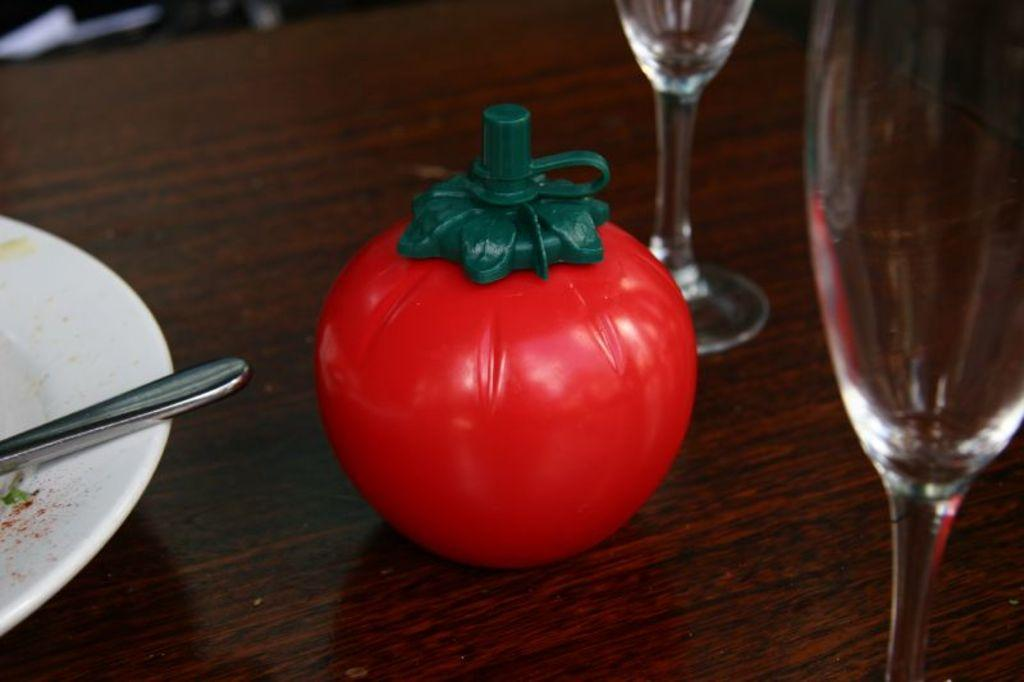What is present on the table in the image? There is a plate, a spoon, glasses, and a jar in the image. What object might be used for eating or stirring in the image? The spoon in the image might be used for eating or stirring. What type of container is present in the image? There is a jar in the image. In which setting is the image taken? The image is taken in a room. Are there any trees visible in the image? No, there are no trees visible in the image. Is there a flower on the table in the image? No, there is no flower present on the table in the image. 